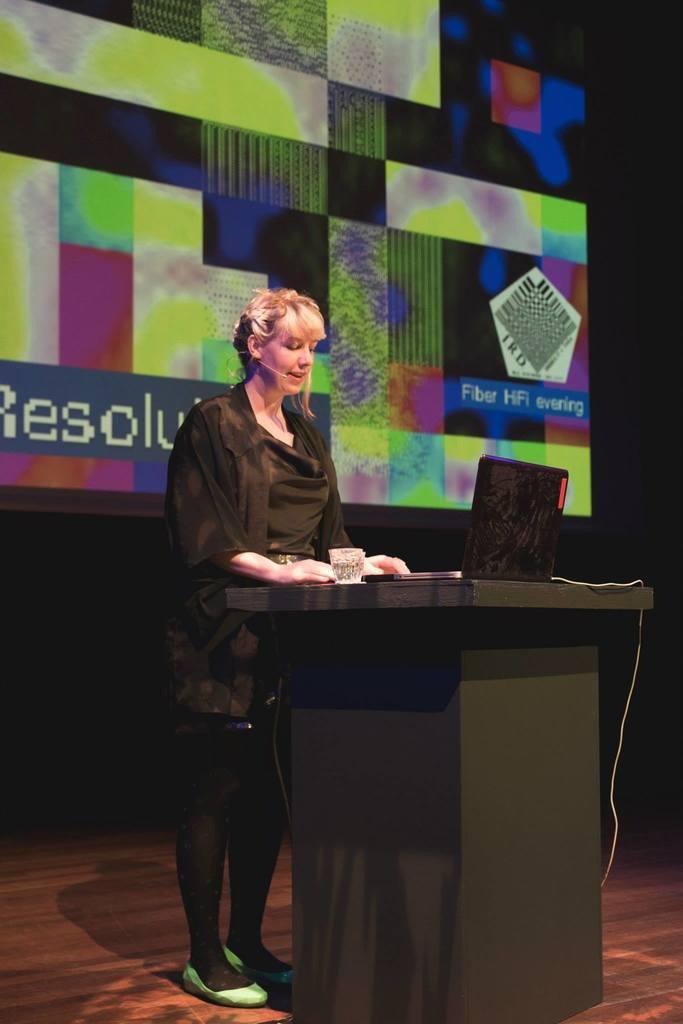Please provide a concise description of this image. In the middle of the image there is a podium, on the podium there is a laptop and glass. Behind the podium a woman is standing and looking into the laptop. Behind her there is a screen. 